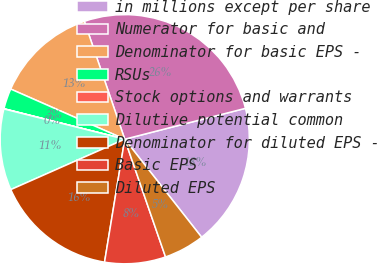Convert chart. <chart><loc_0><loc_0><loc_500><loc_500><pie_chart><fcel>in millions except per share<fcel>Numerator for basic and<fcel>Denominator for basic EPS -<fcel>RSUs<fcel>Stock options and warrants<fcel>Dilutive potential common<fcel>Denominator for diluted EPS -<fcel>Basic EPS<fcel>Diluted EPS<nl><fcel>18.4%<fcel>26.27%<fcel>13.15%<fcel>2.66%<fcel>0.03%<fcel>10.53%<fcel>15.78%<fcel>7.9%<fcel>5.28%<nl></chart> 